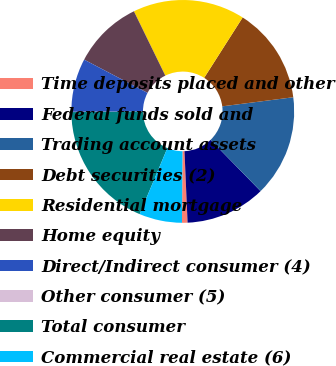Convert chart to OTSL. <chart><loc_0><loc_0><loc_500><loc_500><pie_chart><fcel>Time deposits placed and other<fcel>Federal funds sold and<fcel>Trading account assets<fcel>Debt securities (2)<fcel>Residential mortgage<fcel>Home equity<fcel>Direct/Indirect consumer (4)<fcel>Other consumer (5)<fcel>Total consumer<fcel>Commercial real estate (6)<nl><fcel>0.8%<fcel>11.62%<fcel>14.72%<fcel>13.94%<fcel>16.26%<fcel>10.08%<fcel>7.76%<fcel>0.03%<fcel>18.58%<fcel>6.21%<nl></chart> 